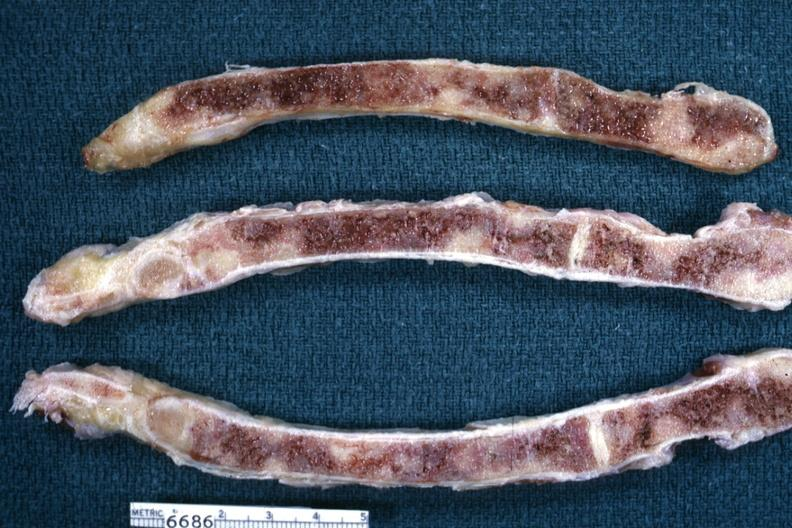s joints present?
Answer the question using a single word or phrase. Yes 